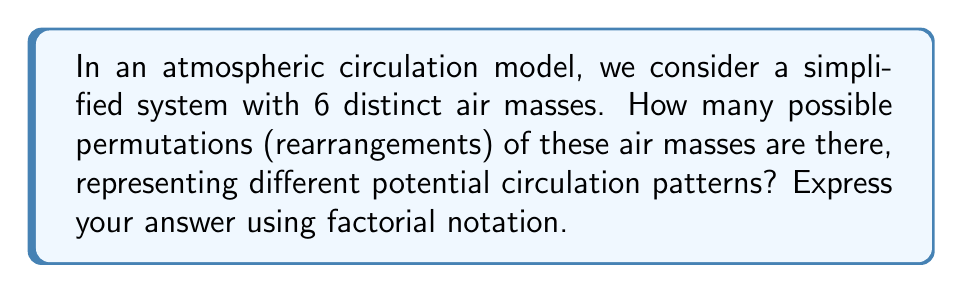Give your solution to this math problem. To solve this problem, we need to understand the concept of permutations in group theory, which is directly applicable to atmospheric circulation models.

1) In this simplified model, we have 6 distinct air masses. Each permutation represents a unique arrangement of these air masses, which could correspond to different circulation patterns in the atmosphere.

2) In permutation group theory, the number of permutations of n distinct objects is given by n!, where n! (n factorial) is the product of all positive integers less than or equal to n.

3) In this case, n = 6, so we need to calculate 6!

4) Let's expand this:

   $$6! = 6 \times 5 \times 4 \times 3 \times 2 \times 1$$

5) Multiplying these numbers:

   $$6! = 720$$

Therefore, there are 720 possible permutations of the 6 air masses in this simplified atmospheric circulation model.

This result is significant in meteorology as it represents the total number of possible arrangements of these air masses, each of which could potentially lead to different weather patterns. Understanding these permutations can help in developing more comprehensive atmospheric circulation models and improving weather predictions.
Answer: $6!$ or 720 permutations 